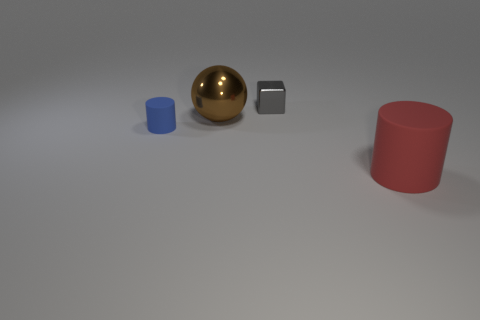What number of red matte objects are the same shape as the blue thing?
Provide a short and direct response. 1. Is the number of big brown objects in front of the blue matte thing greater than the number of large metallic balls that are in front of the gray block?
Keep it short and to the point. No. Do the large matte cylinder and the cylinder that is on the left side of the red matte cylinder have the same color?
Keep it short and to the point. No. There is a block that is the same size as the blue matte cylinder; what is its material?
Ensure brevity in your answer.  Metal. What number of things are either red cylinders or shiny objects behind the big brown metal sphere?
Your answer should be very brief. 2. Do the metal ball and the rubber cylinder that is in front of the blue matte cylinder have the same size?
Give a very brief answer. Yes. How many cylinders are either big brown rubber objects or red matte things?
Offer a very short reply. 1. How many things are both to the right of the shiny sphere and in front of the tiny gray metal thing?
Ensure brevity in your answer.  1. What number of other things are the same color as the small cylinder?
Your answer should be very brief. 0. What is the shape of the object to the right of the small cube?
Offer a very short reply. Cylinder. 